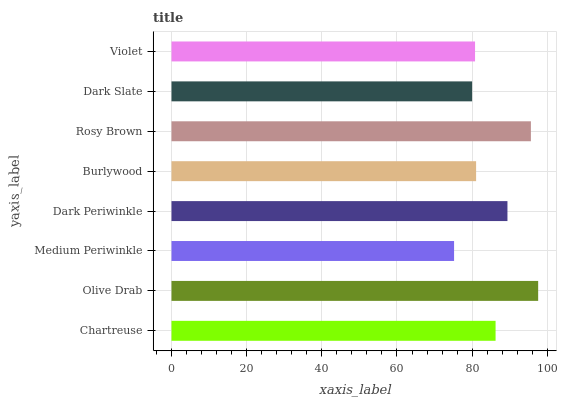Is Medium Periwinkle the minimum?
Answer yes or no. Yes. Is Olive Drab the maximum?
Answer yes or no. Yes. Is Olive Drab the minimum?
Answer yes or no. No. Is Medium Periwinkle the maximum?
Answer yes or no. No. Is Olive Drab greater than Medium Periwinkle?
Answer yes or no. Yes. Is Medium Periwinkle less than Olive Drab?
Answer yes or no. Yes. Is Medium Periwinkle greater than Olive Drab?
Answer yes or no. No. Is Olive Drab less than Medium Periwinkle?
Answer yes or no. No. Is Chartreuse the high median?
Answer yes or no. Yes. Is Burlywood the low median?
Answer yes or no. Yes. Is Rosy Brown the high median?
Answer yes or no. No. Is Medium Periwinkle the low median?
Answer yes or no. No. 